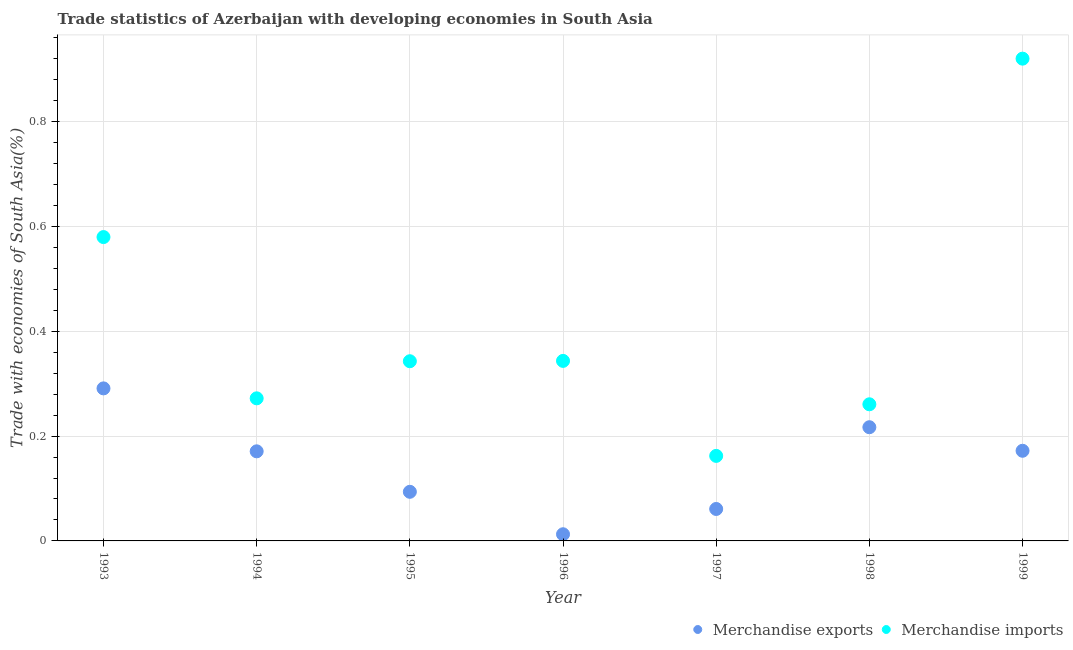Is the number of dotlines equal to the number of legend labels?
Your answer should be very brief. Yes. What is the merchandise imports in 1999?
Provide a succinct answer. 0.92. Across all years, what is the maximum merchandise imports?
Your answer should be very brief. 0.92. Across all years, what is the minimum merchandise imports?
Provide a succinct answer. 0.16. In which year was the merchandise imports minimum?
Your answer should be compact. 1997. What is the total merchandise exports in the graph?
Offer a terse response. 1.02. What is the difference between the merchandise exports in 1995 and that in 1998?
Your answer should be compact. -0.12. What is the difference between the merchandise imports in 1999 and the merchandise exports in 1998?
Provide a succinct answer. 0.7. What is the average merchandise exports per year?
Offer a very short reply. 0.15. In the year 1993, what is the difference between the merchandise imports and merchandise exports?
Your answer should be compact. 0.29. What is the ratio of the merchandise exports in 1993 to that in 1994?
Offer a very short reply. 1.7. What is the difference between the highest and the second highest merchandise exports?
Your answer should be very brief. 0.07. What is the difference between the highest and the lowest merchandise imports?
Provide a short and direct response. 0.76. In how many years, is the merchandise exports greater than the average merchandise exports taken over all years?
Provide a succinct answer. 4. Does the merchandise exports monotonically increase over the years?
Give a very brief answer. No. Is the merchandise imports strictly less than the merchandise exports over the years?
Your response must be concise. No. How many legend labels are there?
Provide a short and direct response. 2. What is the title of the graph?
Provide a short and direct response. Trade statistics of Azerbaijan with developing economies in South Asia. What is the label or title of the Y-axis?
Your answer should be very brief. Trade with economies of South Asia(%). What is the Trade with economies of South Asia(%) in Merchandise exports in 1993?
Provide a short and direct response. 0.29. What is the Trade with economies of South Asia(%) of Merchandise imports in 1993?
Provide a short and direct response. 0.58. What is the Trade with economies of South Asia(%) of Merchandise exports in 1994?
Your answer should be compact. 0.17. What is the Trade with economies of South Asia(%) of Merchandise imports in 1994?
Provide a succinct answer. 0.27. What is the Trade with economies of South Asia(%) in Merchandise exports in 1995?
Offer a terse response. 0.09. What is the Trade with economies of South Asia(%) in Merchandise imports in 1995?
Your answer should be very brief. 0.34. What is the Trade with economies of South Asia(%) of Merchandise exports in 1996?
Provide a short and direct response. 0.01. What is the Trade with economies of South Asia(%) in Merchandise imports in 1996?
Make the answer very short. 0.34. What is the Trade with economies of South Asia(%) in Merchandise exports in 1997?
Your response must be concise. 0.06. What is the Trade with economies of South Asia(%) of Merchandise imports in 1997?
Provide a succinct answer. 0.16. What is the Trade with economies of South Asia(%) in Merchandise exports in 1998?
Offer a terse response. 0.22. What is the Trade with economies of South Asia(%) in Merchandise imports in 1998?
Keep it short and to the point. 0.26. What is the Trade with economies of South Asia(%) of Merchandise exports in 1999?
Your answer should be compact. 0.17. What is the Trade with economies of South Asia(%) of Merchandise imports in 1999?
Your answer should be very brief. 0.92. Across all years, what is the maximum Trade with economies of South Asia(%) in Merchandise exports?
Offer a terse response. 0.29. Across all years, what is the maximum Trade with economies of South Asia(%) of Merchandise imports?
Your response must be concise. 0.92. Across all years, what is the minimum Trade with economies of South Asia(%) of Merchandise exports?
Your response must be concise. 0.01. Across all years, what is the minimum Trade with economies of South Asia(%) in Merchandise imports?
Make the answer very short. 0.16. What is the total Trade with economies of South Asia(%) in Merchandise exports in the graph?
Your answer should be very brief. 1.02. What is the total Trade with economies of South Asia(%) of Merchandise imports in the graph?
Your answer should be compact. 2.88. What is the difference between the Trade with economies of South Asia(%) of Merchandise exports in 1993 and that in 1994?
Your answer should be very brief. 0.12. What is the difference between the Trade with economies of South Asia(%) in Merchandise imports in 1993 and that in 1994?
Keep it short and to the point. 0.31. What is the difference between the Trade with economies of South Asia(%) of Merchandise exports in 1993 and that in 1995?
Keep it short and to the point. 0.2. What is the difference between the Trade with economies of South Asia(%) of Merchandise imports in 1993 and that in 1995?
Your answer should be very brief. 0.24. What is the difference between the Trade with economies of South Asia(%) of Merchandise exports in 1993 and that in 1996?
Your answer should be compact. 0.28. What is the difference between the Trade with economies of South Asia(%) in Merchandise imports in 1993 and that in 1996?
Your response must be concise. 0.24. What is the difference between the Trade with economies of South Asia(%) of Merchandise exports in 1993 and that in 1997?
Your answer should be compact. 0.23. What is the difference between the Trade with economies of South Asia(%) in Merchandise imports in 1993 and that in 1997?
Offer a terse response. 0.42. What is the difference between the Trade with economies of South Asia(%) in Merchandise exports in 1993 and that in 1998?
Your answer should be very brief. 0.07. What is the difference between the Trade with economies of South Asia(%) of Merchandise imports in 1993 and that in 1998?
Provide a short and direct response. 0.32. What is the difference between the Trade with economies of South Asia(%) of Merchandise exports in 1993 and that in 1999?
Ensure brevity in your answer.  0.12. What is the difference between the Trade with economies of South Asia(%) in Merchandise imports in 1993 and that in 1999?
Provide a short and direct response. -0.34. What is the difference between the Trade with economies of South Asia(%) of Merchandise exports in 1994 and that in 1995?
Offer a terse response. 0.08. What is the difference between the Trade with economies of South Asia(%) in Merchandise imports in 1994 and that in 1995?
Provide a short and direct response. -0.07. What is the difference between the Trade with economies of South Asia(%) in Merchandise exports in 1994 and that in 1996?
Your answer should be very brief. 0.16. What is the difference between the Trade with economies of South Asia(%) of Merchandise imports in 1994 and that in 1996?
Your response must be concise. -0.07. What is the difference between the Trade with economies of South Asia(%) of Merchandise exports in 1994 and that in 1997?
Offer a terse response. 0.11. What is the difference between the Trade with economies of South Asia(%) of Merchandise imports in 1994 and that in 1997?
Give a very brief answer. 0.11. What is the difference between the Trade with economies of South Asia(%) in Merchandise exports in 1994 and that in 1998?
Provide a succinct answer. -0.05. What is the difference between the Trade with economies of South Asia(%) of Merchandise imports in 1994 and that in 1998?
Offer a very short reply. 0.01. What is the difference between the Trade with economies of South Asia(%) in Merchandise exports in 1994 and that in 1999?
Your response must be concise. -0. What is the difference between the Trade with economies of South Asia(%) of Merchandise imports in 1994 and that in 1999?
Provide a succinct answer. -0.65. What is the difference between the Trade with economies of South Asia(%) of Merchandise exports in 1995 and that in 1996?
Your response must be concise. 0.08. What is the difference between the Trade with economies of South Asia(%) in Merchandise imports in 1995 and that in 1996?
Keep it short and to the point. -0. What is the difference between the Trade with economies of South Asia(%) of Merchandise exports in 1995 and that in 1997?
Offer a very short reply. 0.03. What is the difference between the Trade with economies of South Asia(%) in Merchandise imports in 1995 and that in 1997?
Your response must be concise. 0.18. What is the difference between the Trade with economies of South Asia(%) in Merchandise exports in 1995 and that in 1998?
Provide a succinct answer. -0.12. What is the difference between the Trade with economies of South Asia(%) of Merchandise imports in 1995 and that in 1998?
Provide a short and direct response. 0.08. What is the difference between the Trade with economies of South Asia(%) of Merchandise exports in 1995 and that in 1999?
Your response must be concise. -0.08. What is the difference between the Trade with economies of South Asia(%) in Merchandise imports in 1995 and that in 1999?
Offer a terse response. -0.58. What is the difference between the Trade with economies of South Asia(%) of Merchandise exports in 1996 and that in 1997?
Your answer should be compact. -0.05. What is the difference between the Trade with economies of South Asia(%) in Merchandise imports in 1996 and that in 1997?
Your answer should be compact. 0.18. What is the difference between the Trade with economies of South Asia(%) of Merchandise exports in 1996 and that in 1998?
Make the answer very short. -0.2. What is the difference between the Trade with economies of South Asia(%) of Merchandise imports in 1996 and that in 1998?
Provide a succinct answer. 0.08. What is the difference between the Trade with economies of South Asia(%) in Merchandise exports in 1996 and that in 1999?
Offer a very short reply. -0.16. What is the difference between the Trade with economies of South Asia(%) in Merchandise imports in 1996 and that in 1999?
Offer a terse response. -0.58. What is the difference between the Trade with economies of South Asia(%) of Merchandise exports in 1997 and that in 1998?
Provide a short and direct response. -0.16. What is the difference between the Trade with economies of South Asia(%) of Merchandise imports in 1997 and that in 1998?
Provide a short and direct response. -0.1. What is the difference between the Trade with economies of South Asia(%) of Merchandise exports in 1997 and that in 1999?
Keep it short and to the point. -0.11. What is the difference between the Trade with economies of South Asia(%) in Merchandise imports in 1997 and that in 1999?
Provide a succinct answer. -0.76. What is the difference between the Trade with economies of South Asia(%) in Merchandise exports in 1998 and that in 1999?
Give a very brief answer. 0.04. What is the difference between the Trade with economies of South Asia(%) in Merchandise imports in 1998 and that in 1999?
Your response must be concise. -0.66. What is the difference between the Trade with economies of South Asia(%) in Merchandise exports in 1993 and the Trade with economies of South Asia(%) in Merchandise imports in 1994?
Keep it short and to the point. 0.02. What is the difference between the Trade with economies of South Asia(%) in Merchandise exports in 1993 and the Trade with economies of South Asia(%) in Merchandise imports in 1995?
Keep it short and to the point. -0.05. What is the difference between the Trade with economies of South Asia(%) of Merchandise exports in 1993 and the Trade with economies of South Asia(%) of Merchandise imports in 1996?
Provide a succinct answer. -0.05. What is the difference between the Trade with economies of South Asia(%) of Merchandise exports in 1993 and the Trade with economies of South Asia(%) of Merchandise imports in 1997?
Ensure brevity in your answer.  0.13. What is the difference between the Trade with economies of South Asia(%) of Merchandise exports in 1993 and the Trade with economies of South Asia(%) of Merchandise imports in 1998?
Your answer should be compact. 0.03. What is the difference between the Trade with economies of South Asia(%) in Merchandise exports in 1993 and the Trade with economies of South Asia(%) in Merchandise imports in 1999?
Provide a succinct answer. -0.63. What is the difference between the Trade with economies of South Asia(%) of Merchandise exports in 1994 and the Trade with economies of South Asia(%) of Merchandise imports in 1995?
Provide a short and direct response. -0.17. What is the difference between the Trade with economies of South Asia(%) of Merchandise exports in 1994 and the Trade with economies of South Asia(%) of Merchandise imports in 1996?
Provide a short and direct response. -0.17. What is the difference between the Trade with economies of South Asia(%) in Merchandise exports in 1994 and the Trade with economies of South Asia(%) in Merchandise imports in 1997?
Give a very brief answer. 0.01. What is the difference between the Trade with economies of South Asia(%) in Merchandise exports in 1994 and the Trade with economies of South Asia(%) in Merchandise imports in 1998?
Provide a succinct answer. -0.09. What is the difference between the Trade with economies of South Asia(%) in Merchandise exports in 1994 and the Trade with economies of South Asia(%) in Merchandise imports in 1999?
Make the answer very short. -0.75. What is the difference between the Trade with economies of South Asia(%) in Merchandise exports in 1995 and the Trade with economies of South Asia(%) in Merchandise imports in 1996?
Make the answer very short. -0.25. What is the difference between the Trade with economies of South Asia(%) of Merchandise exports in 1995 and the Trade with economies of South Asia(%) of Merchandise imports in 1997?
Your answer should be compact. -0.07. What is the difference between the Trade with economies of South Asia(%) in Merchandise exports in 1995 and the Trade with economies of South Asia(%) in Merchandise imports in 1998?
Provide a short and direct response. -0.17. What is the difference between the Trade with economies of South Asia(%) in Merchandise exports in 1995 and the Trade with economies of South Asia(%) in Merchandise imports in 1999?
Offer a very short reply. -0.83. What is the difference between the Trade with economies of South Asia(%) in Merchandise exports in 1996 and the Trade with economies of South Asia(%) in Merchandise imports in 1997?
Your answer should be very brief. -0.15. What is the difference between the Trade with economies of South Asia(%) of Merchandise exports in 1996 and the Trade with economies of South Asia(%) of Merchandise imports in 1998?
Make the answer very short. -0.25. What is the difference between the Trade with economies of South Asia(%) of Merchandise exports in 1996 and the Trade with economies of South Asia(%) of Merchandise imports in 1999?
Keep it short and to the point. -0.91. What is the difference between the Trade with economies of South Asia(%) in Merchandise exports in 1997 and the Trade with economies of South Asia(%) in Merchandise imports in 1998?
Keep it short and to the point. -0.2. What is the difference between the Trade with economies of South Asia(%) in Merchandise exports in 1997 and the Trade with economies of South Asia(%) in Merchandise imports in 1999?
Give a very brief answer. -0.86. What is the difference between the Trade with economies of South Asia(%) in Merchandise exports in 1998 and the Trade with economies of South Asia(%) in Merchandise imports in 1999?
Give a very brief answer. -0.7. What is the average Trade with economies of South Asia(%) of Merchandise exports per year?
Your answer should be very brief. 0.15. What is the average Trade with economies of South Asia(%) in Merchandise imports per year?
Keep it short and to the point. 0.41. In the year 1993, what is the difference between the Trade with economies of South Asia(%) in Merchandise exports and Trade with economies of South Asia(%) in Merchandise imports?
Make the answer very short. -0.29. In the year 1994, what is the difference between the Trade with economies of South Asia(%) in Merchandise exports and Trade with economies of South Asia(%) in Merchandise imports?
Offer a very short reply. -0.1. In the year 1995, what is the difference between the Trade with economies of South Asia(%) of Merchandise exports and Trade with economies of South Asia(%) of Merchandise imports?
Your answer should be compact. -0.25. In the year 1996, what is the difference between the Trade with economies of South Asia(%) of Merchandise exports and Trade with economies of South Asia(%) of Merchandise imports?
Provide a short and direct response. -0.33. In the year 1997, what is the difference between the Trade with economies of South Asia(%) of Merchandise exports and Trade with economies of South Asia(%) of Merchandise imports?
Provide a short and direct response. -0.1. In the year 1998, what is the difference between the Trade with economies of South Asia(%) of Merchandise exports and Trade with economies of South Asia(%) of Merchandise imports?
Ensure brevity in your answer.  -0.04. In the year 1999, what is the difference between the Trade with economies of South Asia(%) in Merchandise exports and Trade with economies of South Asia(%) in Merchandise imports?
Keep it short and to the point. -0.75. What is the ratio of the Trade with economies of South Asia(%) in Merchandise exports in 1993 to that in 1994?
Your answer should be compact. 1.7. What is the ratio of the Trade with economies of South Asia(%) of Merchandise imports in 1993 to that in 1994?
Your answer should be very brief. 2.13. What is the ratio of the Trade with economies of South Asia(%) in Merchandise exports in 1993 to that in 1995?
Make the answer very short. 3.11. What is the ratio of the Trade with economies of South Asia(%) in Merchandise imports in 1993 to that in 1995?
Your response must be concise. 1.69. What is the ratio of the Trade with economies of South Asia(%) of Merchandise exports in 1993 to that in 1996?
Offer a terse response. 22.87. What is the ratio of the Trade with economies of South Asia(%) in Merchandise imports in 1993 to that in 1996?
Your answer should be compact. 1.69. What is the ratio of the Trade with economies of South Asia(%) in Merchandise exports in 1993 to that in 1997?
Your answer should be very brief. 4.77. What is the ratio of the Trade with economies of South Asia(%) of Merchandise imports in 1993 to that in 1997?
Offer a terse response. 3.57. What is the ratio of the Trade with economies of South Asia(%) of Merchandise exports in 1993 to that in 1998?
Provide a short and direct response. 1.34. What is the ratio of the Trade with economies of South Asia(%) in Merchandise imports in 1993 to that in 1998?
Provide a succinct answer. 2.22. What is the ratio of the Trade with economies of South Asia(%) in Merchandise exports in 1993 to that in 1999?
Offer a very short reply. 1.69. What is the ratio of the Trade with economies of South Asia(%) in Merchandise imports in 1993 to that in 1999?
Ensure brevity in your answer.  0.63. What is the ratio of the Trade with economies of South Asia(%) of Merchandise exports in 1994 to that in 1995?
Make the answer very short. 1.82. What is the ratio of the Trade with economies of South Asia(%) in Merchandise imports in 1994 to that in 1995?
Provide a succinct answer. 0.79. What is the ratio of the Trade with economies of South Asia(%) of Merchandise exports in 1994 to that in 1996?
Your answer should be very brief. 13.44. What is the ratio of the Trade with economies of South Asia(%) in Merchandise imports in 1994 to that in 1996?
Your answer should be very brief. 0.79. What is the ratio of the Trade with economies of South Asia(%) of Merchandise exports in 1994 to that in 1997?
Your response must be concise. 2.8. What is the ratio of the Trade with economies of South Asia(%) in Merchandise imports in 1994 to that in 1997?
Your response must be concise. 1.68. What is the ratio of the Trade with economies of South Asia(%) in Merchandise exports in 1994 to that in 1998?
Your answer should be very brief. 0.79. What is the ratio of the Trade with economies of South Asia(%) of Merchandise imports in 1994 to that in 1998?
Provide a succinct answer. 1.04. What is the ratio of the Trade with economies of South Asia(%) in Merchandise exports in 1994 to that in 1999?
Your answer should be very brief. 0.99. What is the ratio of the Trade with economies of South Asia(%) of Merchandise imports in 1994 to that in 1999?
Provide a short and direct response. 0.3. What is the ratio of the Trade with economies of South Asia(%) of Merchandise exports in 1995 to that in 1996?
Offer a terse response. 7.37. What is the ratio of the Trade with economies of South Asia(%) of Merchandise exports in 1995 to that in 1997?
Offer a very short reply. 1.54. What is the ratio of the Trade with economies of South Asia(%) in Merchandise imports in 1995 to that in 1997?
Keep it short and to the point. 2.11. What is the ratio of the Trade with economies of South Asia(%) of Merchandise exports in 1995 to that in 1998?
Provide a succinct answer. 0.43. What is the ratio of the Trade with economies of South Asia(%) of Merchandise imports in 1995 to that in 1998?
Offer a terse response. 1.32. What is the ratio of the Trade with economies of South Asia(%) in Merchandise exports in 1995 to that in 1999?
Your answer should be compact. 0.54. What is the ratio of the Trade with economies of South Asia(%) of Merchandise imports in 1995 to that in 1999?
Your response must be concise. 0.37. What is the ratio of the Trade with economies of South Asia(%) in Merchandise exports in 1996 to that in 1997?
Ensure brevity in your answer.  0.21. What is the ratio of the Trade with economies of South Asia(%) of Merchandise imports in 1996 to that in 1997?
Your answer should be compact. 2.12. What is the ratio of the Trade with economies of South Asia(%) in Merchandise exports in 1996 to that in 1998?
Offer a very short reply. 0.06. What is the ratio of the Trade with economies of South Asia(%) of Merchandise imports in 1996 to that in 1998?
Offer a terse response. 1.32. What is the ratio of the Trade with economies of South Asia(%) in Merchandise exports in 1996 to that in 1999?
Give a very brief answer. 0.07. What is the ratio of the Trade with economies of South Asia(%) of Merchandise imports in 1996 to that in 1999?
Your answer should be very brief. 0.37. What is the ratio of the Trade with economies of South Asia(%) of Merchandise exports in 1997 to that in 1998?
Keep it short and to the point. 0.28. What is the ratio of the Trade with economies of South Asia(%) in Merchandise imports in 1997 to that in 1998?
Offer a terse response. 0.62. What is the ratio of the Trade with economies of South Asia(%) of Merchandise exports in 1997 to that in 1999?
Give a very brief answer. 0.35. What is the ratio of the Trade with economies of South Asia(%) of Merchandise imports in 1997 to that in 1999?
Offer a terse response. 0.18. What is the ratio of the Trade with economies of South Asia(%) in Merchandise exports in 1998 to that in 1999?
Give a very brief answer. 1.26. What is the ratio of the Trade with economies of South Asia(%) of Merchandise imports in 1998 to that in 1999?
Offer a very short reply. 0.28. What is the difference between the highest and the second highest Trade with economies of South Asia(%) in Merchandise exports?
Keep it short and to the point. 0.07. What is the difference between the highest and the second highest Trade with economies of South Asia(%) of Merchandise imports?
Provide a short and direct response. 0.34. What is the difference between the highest and the lowest Trade with economies of South Asia(%) of Merchandise exports?
Your response must be concise. 0.28. What is the difference between the highest and the lowest Trade with economies of South Asia(%) in Merchandise imports?
Offer a very short reply. 0.76. 